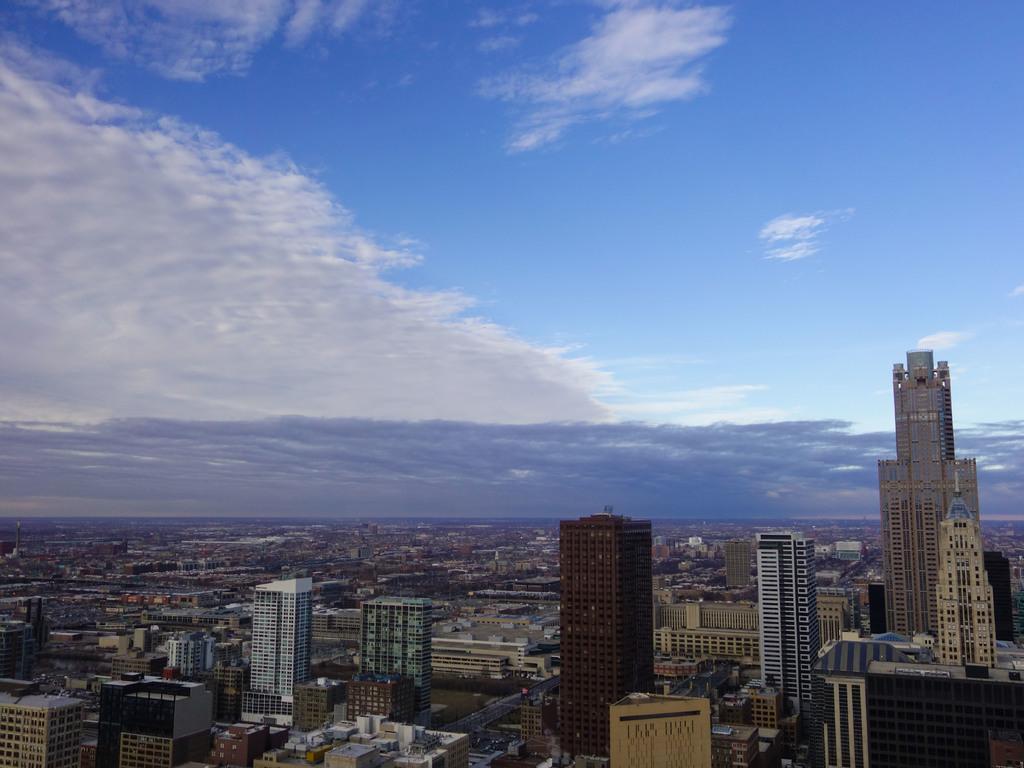How would you summarize this image in a sentence or two? At the bottom of the image there are many buildings. And at the top of the image there is a blue sky with clouds. 